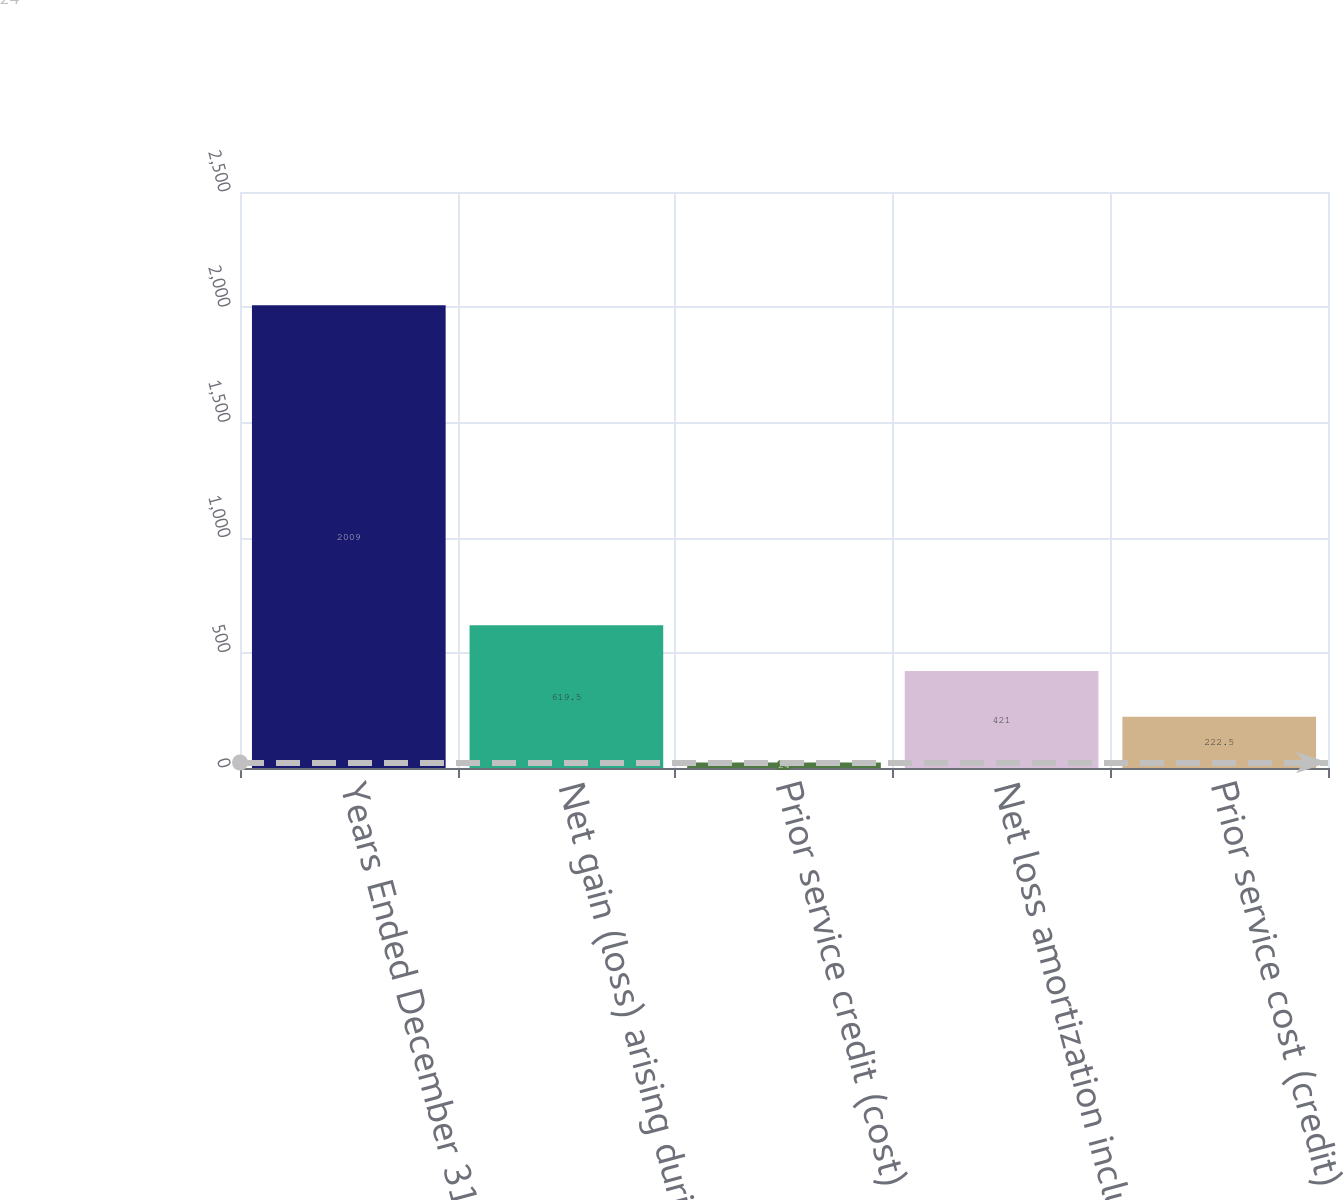<chart> <loc_0><loc_0><loc_500><loc_500><bar_chart><fcel>Years Ended December 31<fcel>Net gain (loss) arising during<fcel>Prior service credit (cost)<fcel>Net loss amortization included<fcel>Prior service cost (credit)<nl><fcel>2009<fcel>619.5<fcel>24<fcel>421<fcel>222.5<nl></chart> 